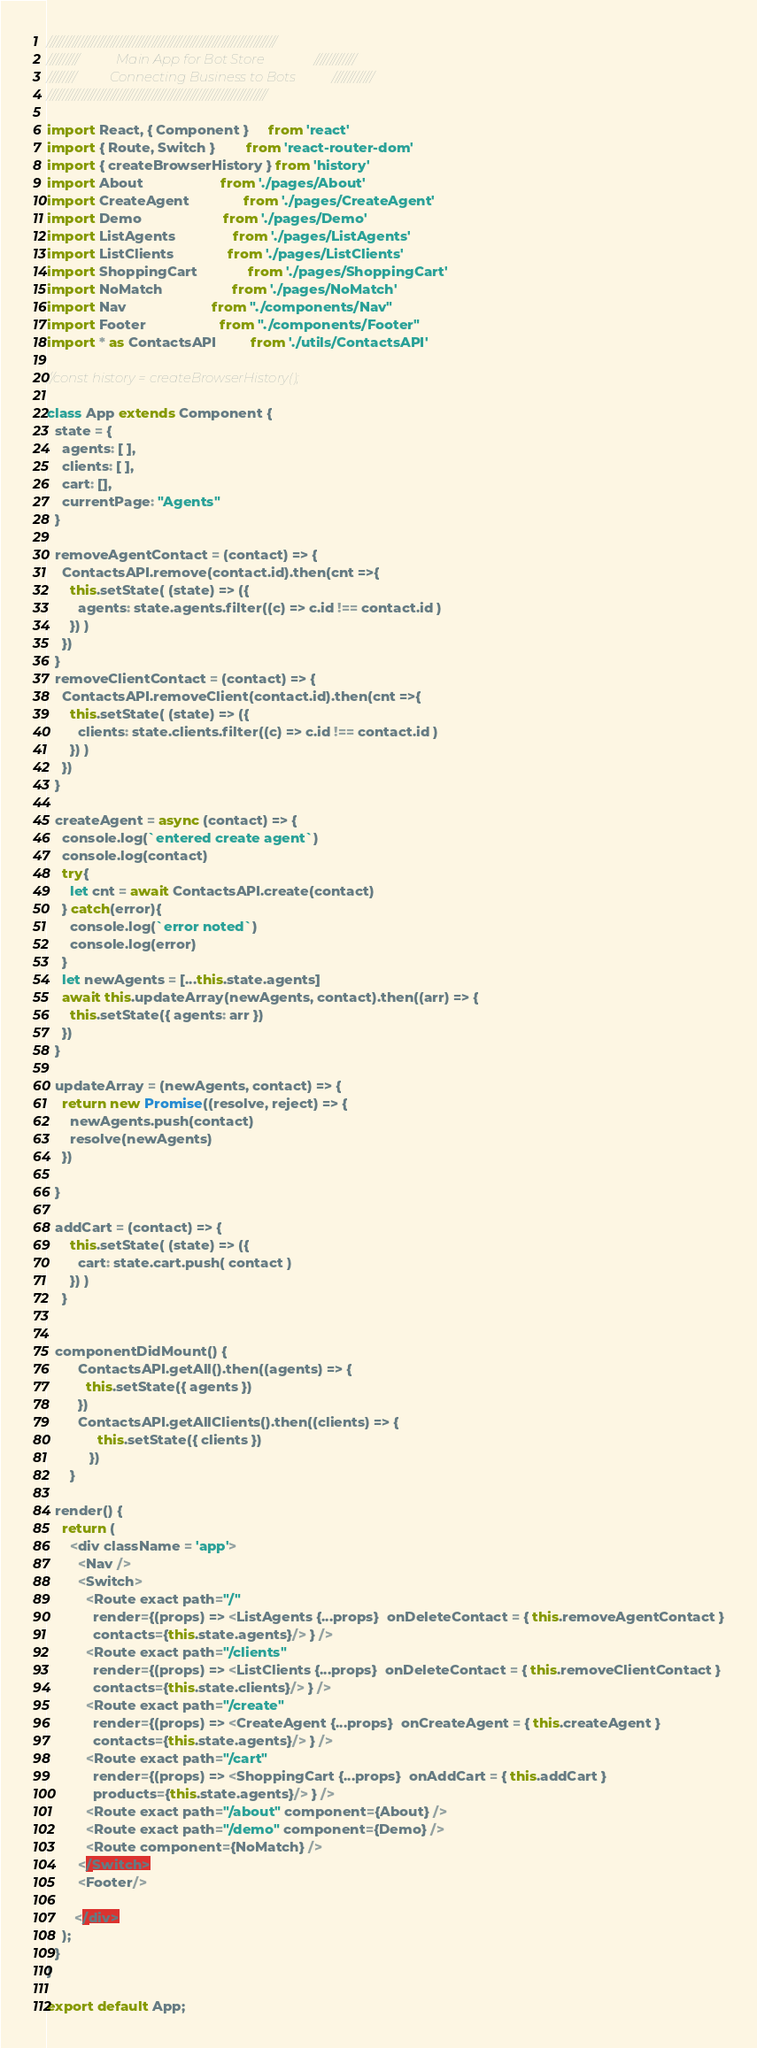<code> <loc_0><loc_0><loc_500><loc_500><_JavaScript_>
////////////////////////////////////////////////////////////////////////
//////////           Main App for Bot Store               /////////////
/////////          Connecting Business to Bots           /////////////
/////////////////////////////////////////////////////////////////////

import React, { Component }     from 'react'
import { Route, Switch }        from 'react-router-dom'
import { createBrowserHistory } from 'history'
import About                    from './pages/About'
import CreateAgent              from './pages/CreateAgent'
import Demo                     from './pages/Demo'
import ListAgents               from './pages/ListAgents'
import ListClients              from './pages/ListClients'
import ShoppingCart             from './pages/ShoppingCart'
import NoMatch                  from './pages/NoMatch'
import Nav                      from "./components/Nav"
import Footer                   from "./components/Footer"
import * as ContactsAPI         from './utils/ContactsAPI'

//const history = createBrowserHistory();

class App extends Component {
  state = {
    agents: [ ],
    clients: [ ],
    cart: [],
    currentPage: "Agents"
  }

  removeAgentContact = (contact) => {
    ContactsAPI.remove(contact.id).then(cnt =>{
      this.setState( (state) => ({
        agents: state.agents.filter((c) => c.id !== contact.id )
      }) )
    })
  }
  removeClientContact = (contact) => {
    ContactsAPI.removeClient(contact.id).then(cnt =>{
      this.setState( (state) => ({
        clients: state.clients.filter((c) => c.id !== contact.id )
      }) )
    })
  }

  createAgent = async (contact) => {
    console.log(`entered create agent`)
    console.log(contact)
    try{
      let cnt = await ContactsAPI.create(contact)
    } catch(error){
      console.log(`error noted`)
      console.log(error)
    }    
    let newAgents = [...this.state.agents]   
    await this.updateArray(newAgents, contact).then((arr) => {     
      this.setState({ agents: arr })        
    })   
  }

  updateArray = (newAgents, contact) => {    
    return new Promise((resolve, reject) => {
      newAgents.push(contact)
      resolve(newAgents)
    })

  }

  addCart = (contact) => { 
      this.setState( (state) => ({
        cart: state.cart.push( contact )
      }) )
    }
  

  componentDidMount() {
        ContactsAPI.getAll().then((agents) => {
          this.setState({ agents })
        })
        ContactsAPI.getAllClients().then((clients) => {
             this.setState({ clients })
           })
      }

  render() {
    return (
      <div className = 'app'>       
        <Nav />
        <Switch>
          <Route exact path="/" 
            render={(props) => <ListAgents {...props}  onDeleteContact = { this.removeAgentContact }
            contacts={this.state.agents}/> } />
          <Route exact path="/clients" 
            render={(props) => <ListClients {...props}  onDeleteContact = { this.removeClientContact }
            contacts={this.state.clients}/> } />
          <Route exact path="/create" 
            render={(props) => <CreateAgent {...props}  onCreateAgent = { this.createAgent }
            contacts={this.state.agents}/> } />
          <Route exact path="/cart" 
            render={(props) => <ShoppingCart {...props}  onAddCart = { this.addCart }
            products={this.state.agents}/> } />
          <Route exact path="/about" component={About} />  
          <Route exact path="/demo" component={Demo} />         
          <Route component={NoMatch} />
        </Switch>
        <Footer/>

       </div>
    );
  }
}

export default App;
</code> 